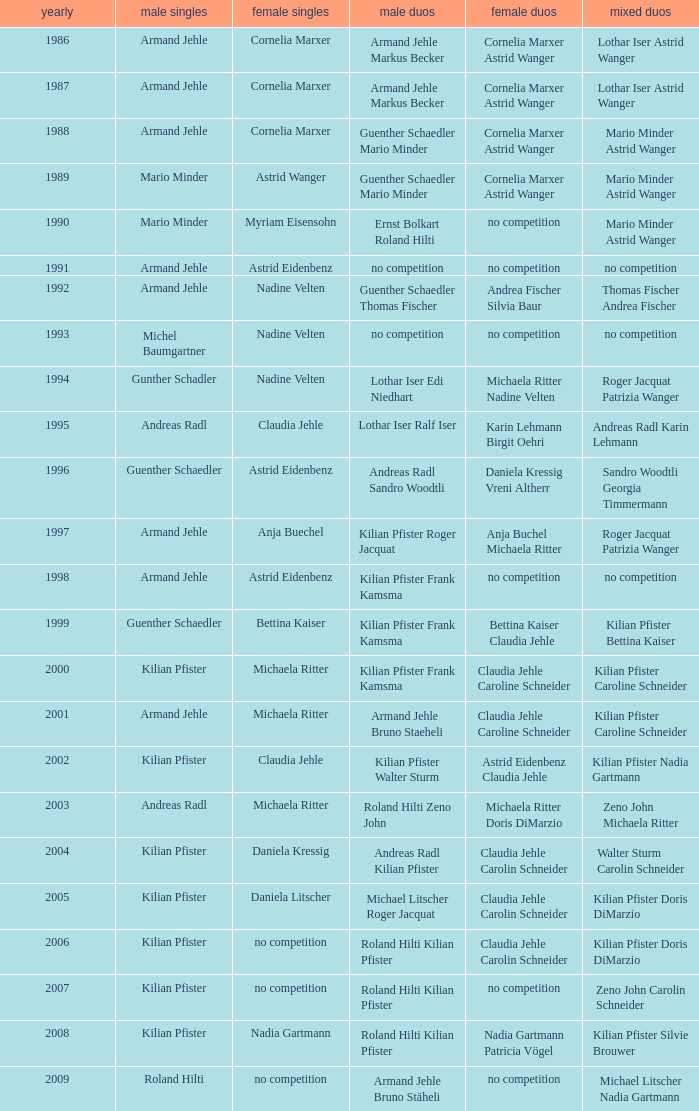In the year 2006, the womens singles had no competition and the mens doubles were roland hilti kilian pfister, what were the womens doubles Claudia Jehle Carolin Schneider. 